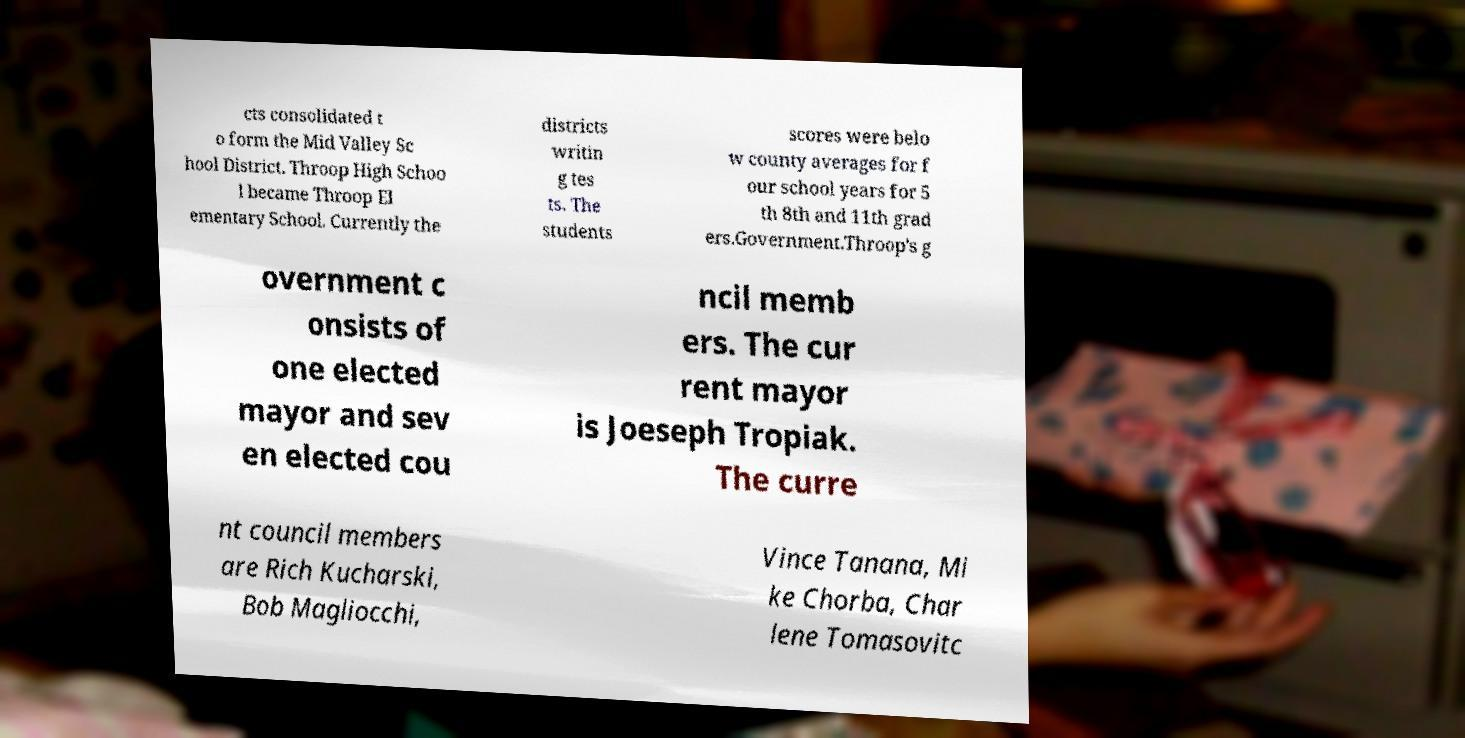Please identify and transcribe the text found in this image. cts consolidated t o form the Mid Valley Sc hool District. Throop High Schoo l became Throop El ementary School. Currently the districts writin g tes ts. The students scores were belo w county averages for f our school years for 5 th 8th and 11th grad ers.Government.Throop's g overnment c onsists of one elected mayor and sev en elected cou ncil memb ers. The cur rent mayor is Joeseph Tropiak. The curre nt council members are Rich Kucharski, Bob Magliocchi, Vince Tanana, Mi ke Chorba, Char lene Tomasovitc 